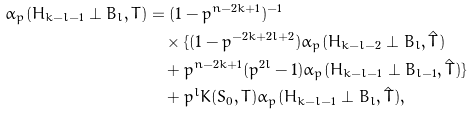Convert formula to latex. <formula><loc_0><loc_0><loc_500><loc_500>\alpha _ { p } ( H _ { k - l - 1 } \perp B _ { l } , T ) & = ( 1 - p ^ { n - 2 k + 1 } ) ^ { - 1 } \\ & \quad \times \{ ( 1 - p ^ { - 2 k + 2 l + 2 } ) \alpha _ { p } ( H _ { k - l - 2 } \perp B _ { l } , \hat { T } ) \\ & \quad + p ^ { n - 2 k + 1 } ( p ^ { 2 l } - 1 ) \alpha _ { p } ( H _ { k - l - 1 } \perp B _ { l - 1 } , \hat { T } ) \} \\ & \quad + p ^ { l } K ( S _ { 0 } , T ) \alpha _ { p } ( H _ { k - l - 1 } \perp B _ { l } , \hat { T } ) ,</formula> 